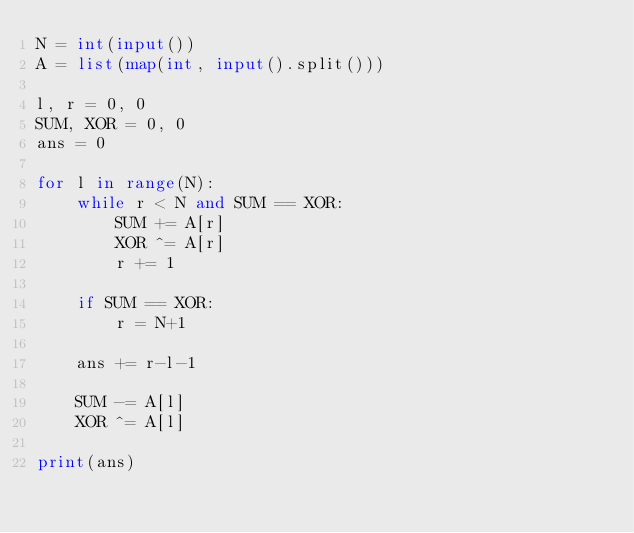<code> <loc_0><loc_0><loc_500><loc_500><_Python_>N = int(input())
A = list(map(int, input().split()))

l, r = 0, 0
SUM, XOR = 0, 0
ans = 0

for l in range(N):
    while r < N and SUM == XOR:
        SUM += A[r]
        XOR ^= A[r]
        r += 1

    if SUM == XOR:
        r = N+1

    ans += r-l-1

    SUM -= A[l]
    XOR ^= A[l]

print(ans)</code> 